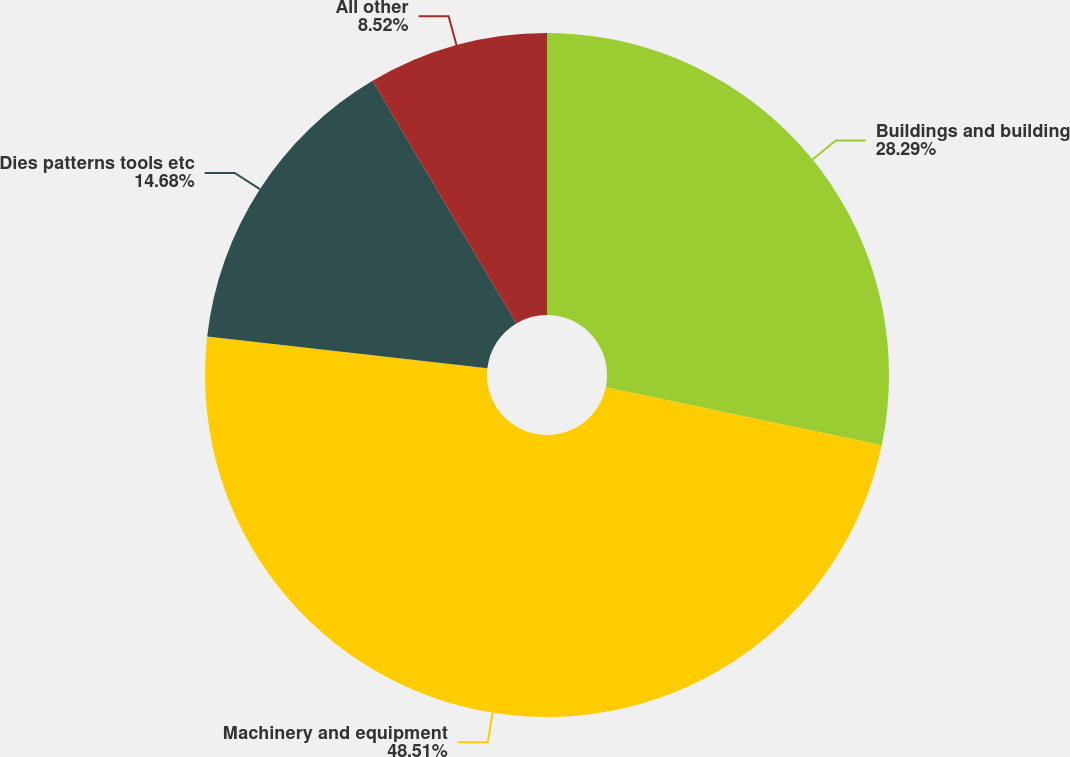Convert chart. <chart><loc_0><loc_0><loc_500><loc_500><pie_chart><fcel>Buildings and building<fcel>Machinery and equipment<fcel>Dies patterns tools etc<fcel>All other<nl><fcel>28.29%<fcel>48.51%<fcel>14.68%<fcel>8.52%<nl></chart> 